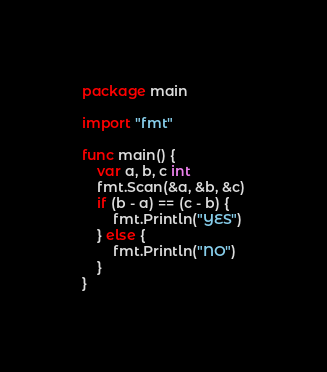<code> <loc_0><loc_0><loc_500><loc_500><_Go_>package main

import "fmt"

func main() {
	var a, b, c int
	fmt.Scan(&a, &b, &c)
	if (b - a) == (c - b) {
		fmt.Println("YES")
	} else {
		fmt.Println("NO")
	}
}
</code> 